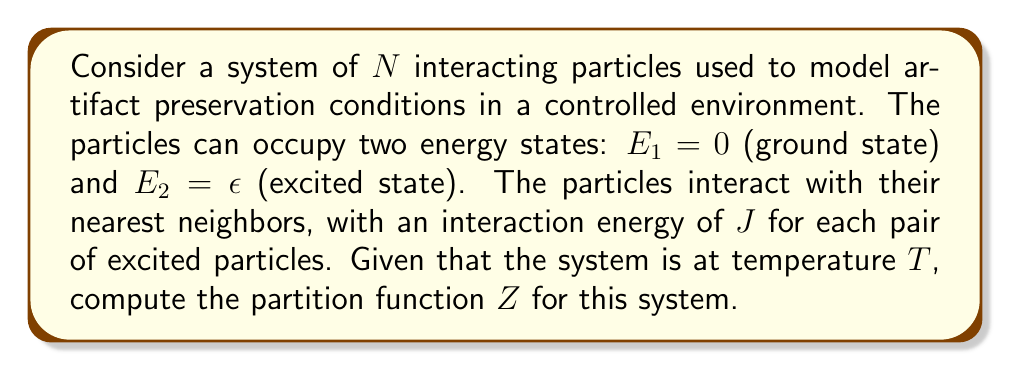Solve this math problem. To compute the partition function, we'll follow these steps:

1) The partition function $Z$ is given by the sum over all possible microstates:

   $$Z = \sum_{\text{all states}} e^{-\beta E}$$

   where $\beta = \frac{1}{k_B T}$, $k_B$ is the Boltzmann constant, and $E$ is the energy of each microstate.

2) In this system, each particle can be in one of two states. The total number of microstates is $2^N$.

3) Let's denote the number of particles in the excited state as $n$. The energy of a microstate with $n$ excited particles is:

   $$E(n) = n\epsilon + \frac{J}{2}n(n-1)$$

   The term $\frac{J}{2}n(n-1)$ accounts for the interactions between excited particles.

4) The number of ways to choose $n$ particles from $N$ particles is given by the binomial coefficient $\binom{N}{n}$.

5) We can now write the partition function as:

   $$Z = \sum_{n=0}^N \binom{N}{n} e^{-\beta(n\epsilon + \frac{J}{2}n(n-1))}$$

6) This sum cannot be simplified further without additional approximations or numerical methods.

7) In the context of artifact preservation, this partition function could be used to calculate thermodynamic properties of the preservation environment, such as average energy or heat capacity, which are crucial for maintaining optimal conditions for artifact conservation.
Answer: $$Z = \sum_{n=0}^N \binom{N}{n} e^{-\beta(n\epsilon + \frac{J}{2}n(n-1))}$$ 